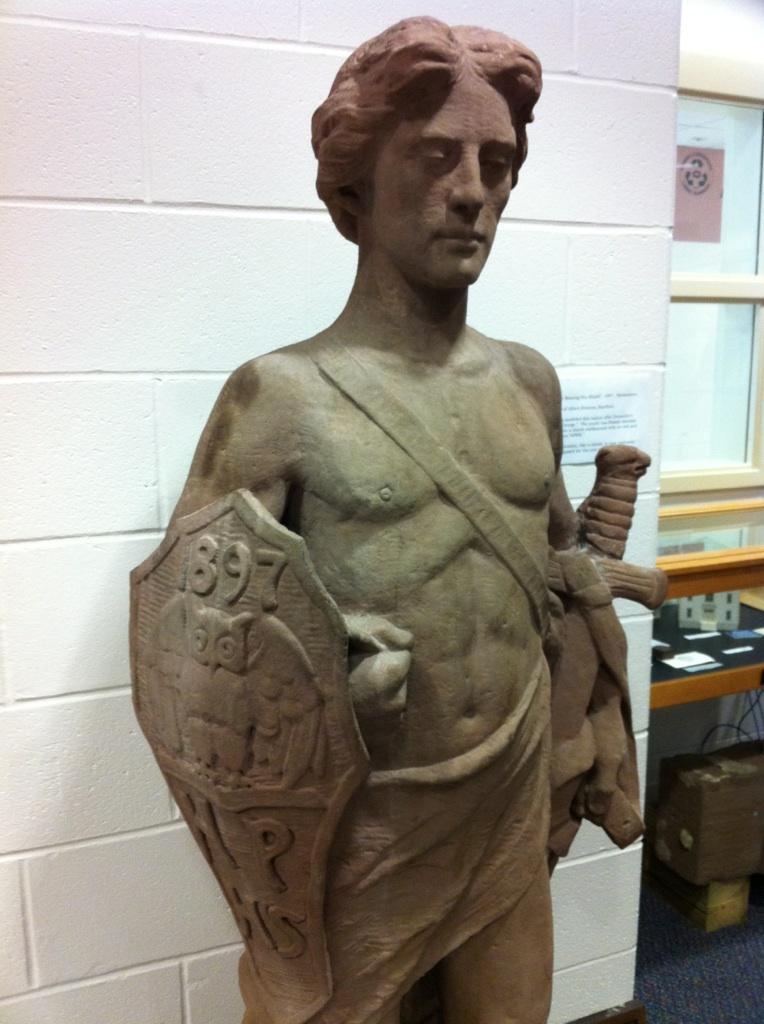Describe this image in one or two sentences. In this image I can see the statue of the person holding the shield and the knife. To the right I can see the table and the window. 